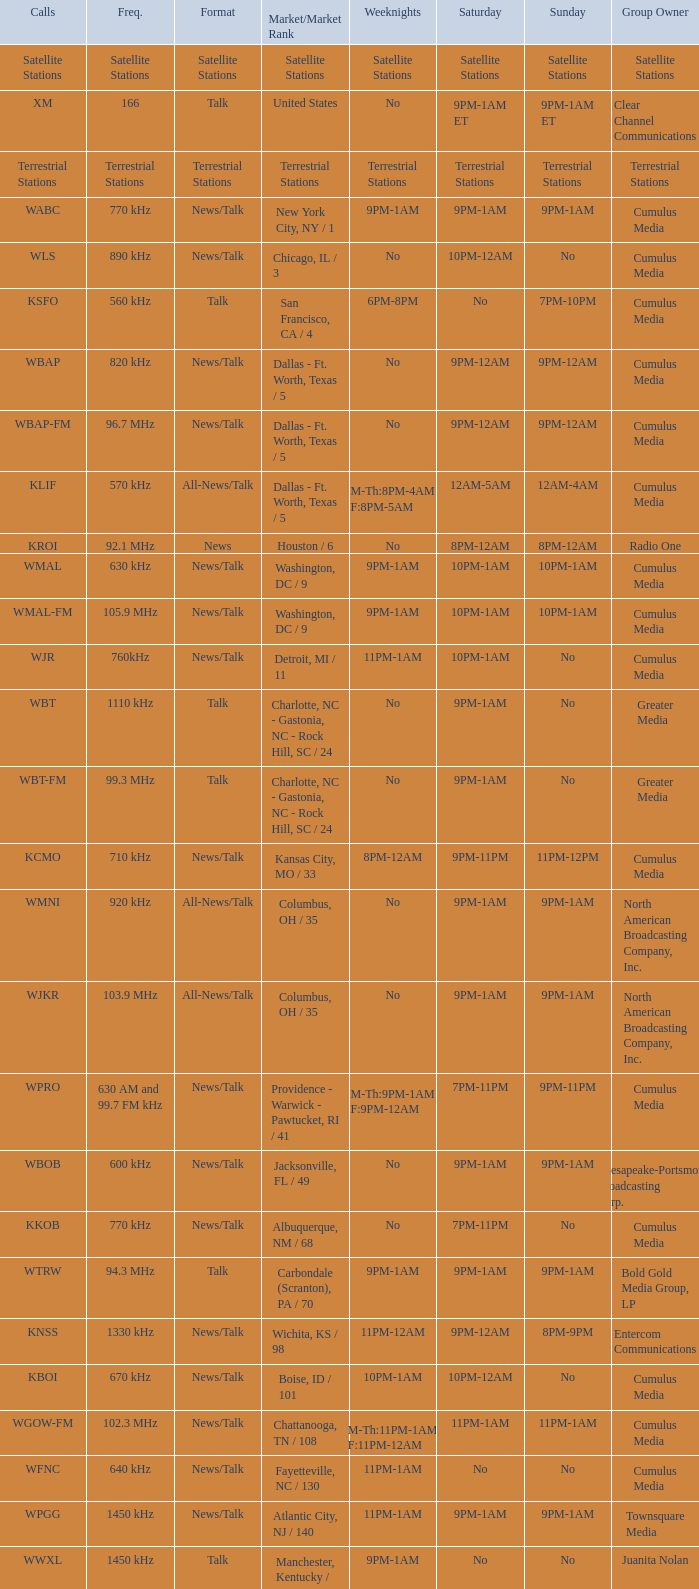What is the demand for the 11pm-1am saturday game? Chattanooga, TN / 108. 